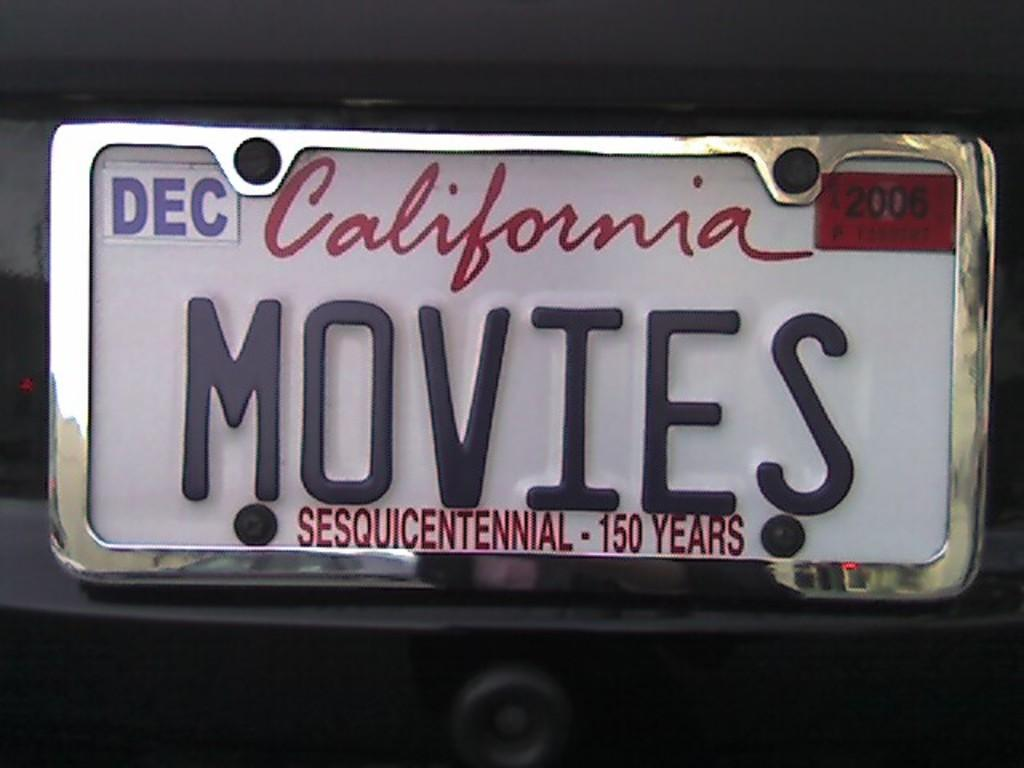Provide a one-sentence caption for the provided image. A California licence says MOVIES and was registered in December. 